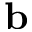Convert formula to latex. <formula><loc_0><loc_0><loc_500><loc_500>{ b }</formula> 